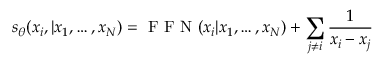<formula> <loc_0><loc_0><loc_500><loc_500>s _ { \theta } ( x _ { i } , | x _ { 1 } , \dots , x _ { N } ) = F F N ( x _ { i } | x _ { 1 } , \dots , x _ { N } ) + \sum _ { j \neq i } \frac { 1 } { x _ { i } - x _ { j } }</formula> 